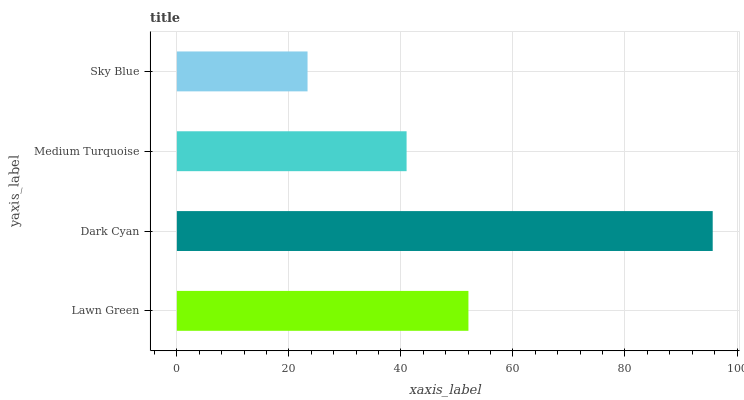Is Sky Blue the minimum?
Answer yes or no. Yes. Is Dark Cyan the maximum?
Answer yes or no. Yes. Is Medium Turquoise the minimum?
Answer yes or no. No. Is Medium Turquoise the maximum?
Answer yes or no. No. Is Dark Cyan greater than Medium Turquoise?
Answer yes or no. Yes. Is Medium Turquoise less than Dark Cyan?
Answer yes or no. Yes. Is Medium Turquoise greater than Dark Cyan?
Answer yes or no. No. Is Dark Cyan less than Medium Turquoise?
Answer yes or no. No. Is Lawn Green the high median?
Answer yes or no. Yes. Is Medium Turquoise the low median?
Answer yes or no. Yes. Is Medium Turquoise the high median?
Answer yes or no. No. Is Sky Blue the low median?
Answer yes or no. No. 